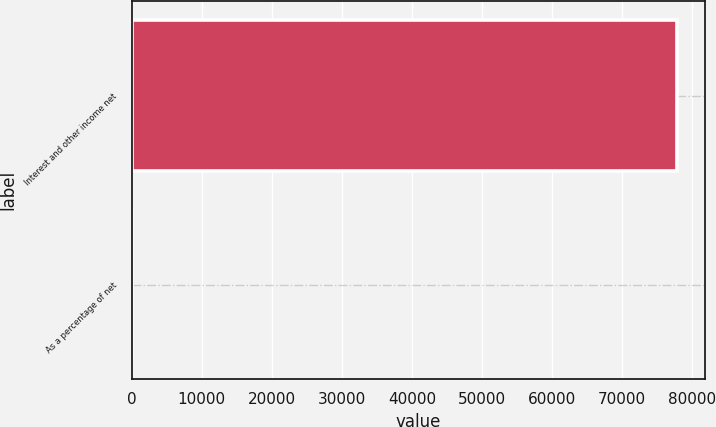Convert chart to OTSL. <chart><loc_0><loc_0><loc_500><loc_500><bar_chart><fcel>Interest and other income net<fcel>As a percentage of net<nl><fcel>77867<fcel>2.4<nl></chart> 